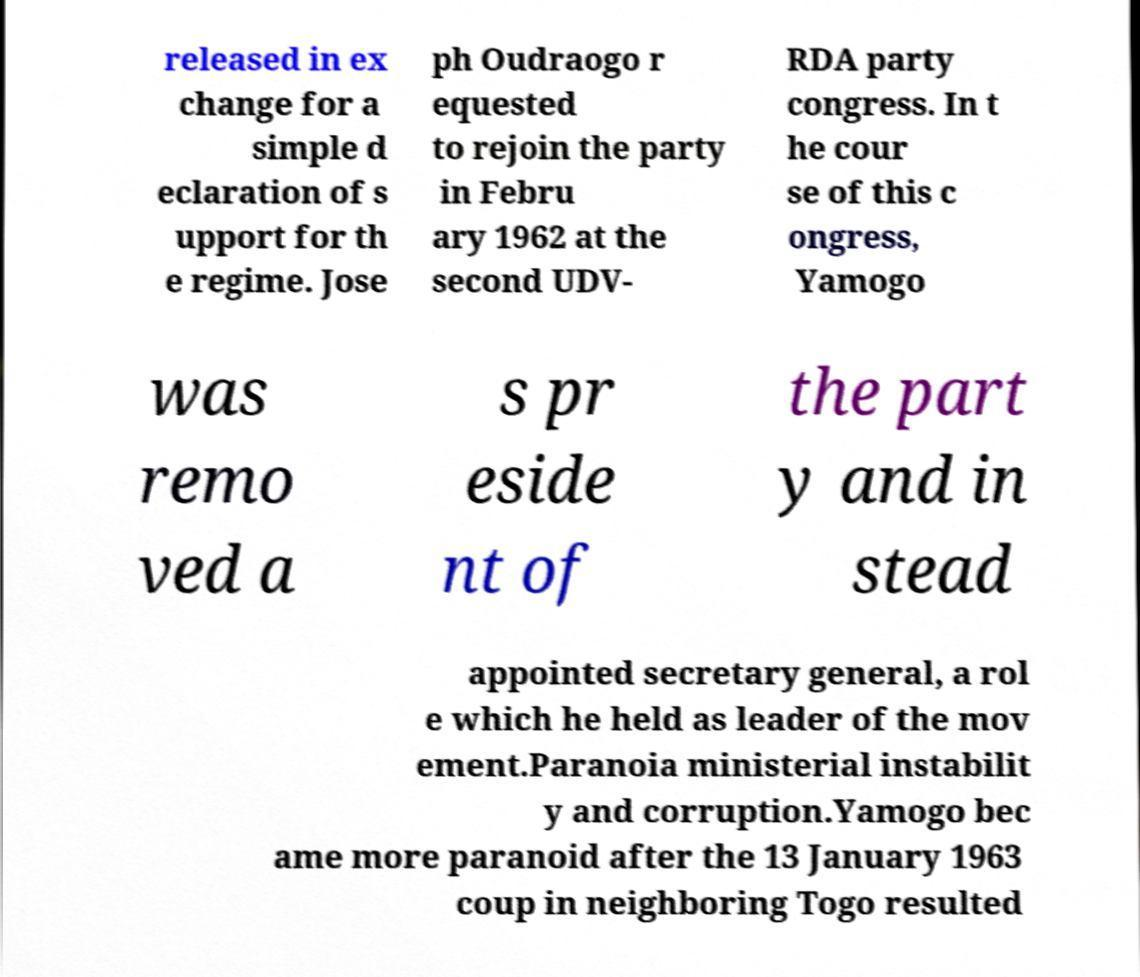What messages or text are displayed in this image? I need them in a readable, typed format. released in ex change for a simple d eclaration of s upport for th e regime. Jose ph Oudraogo r equested to rejoin the party in Febru ary 1962 at the second UDV- RDA party congress. In t he cour se of this c ongress, Yamogo was remo ved a s pr eside nt of the part y and in stead appointed secretary general, a rol e which he held as leader of the mov ement.Paranoia ministerial instabilit y and corruption.Yamogo bec ame more paranoid after the 13 January 1963 coup in neighboring Togo resulted 